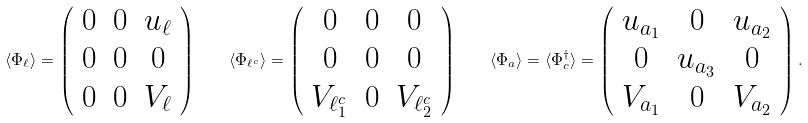Convert formula to latex. <formula><loc_0><loc_0><loc_500><loc_500>\langle \Phi _ { \ell } \rangle = \left ( \begin{array} { c c c } 0 & 0 & u _ { \ell } \\ 0 & 0 & 0 \\ 0 & 0 & V _ { \ell } \end{array} \right ) \quad \langle \Phi _ { \ell ^ { c } } \rangle = \left ( \begin{array} { c c c } 0 & 0 & 0 \\ 0 & 0 & 0 \\ V _ { \ell ^ { c } _ { 1 } } & 0 & V _ { \ell ^ { c } _ { 2 } } \end{array} \right ) \quad \langle \Phi _ { a } \rangle = \langle \Phi _ { c } ^ { \dagger } \rangle = \left ( \begin{array} { c c c } u _ { a _ { 1 } } & 0 & u _ { a _ { 2 } } \\ 0 & u _ { a _ { 3 } } & 0 \\ V _ { a _ { 1 } } & 0 & V _ { a _ { 2 } } \end{array} \right ) .</formula> 